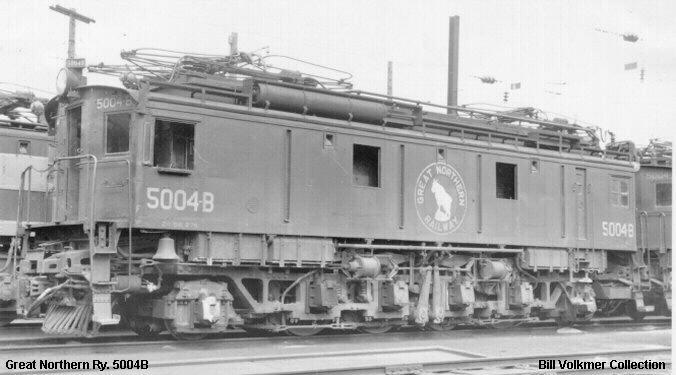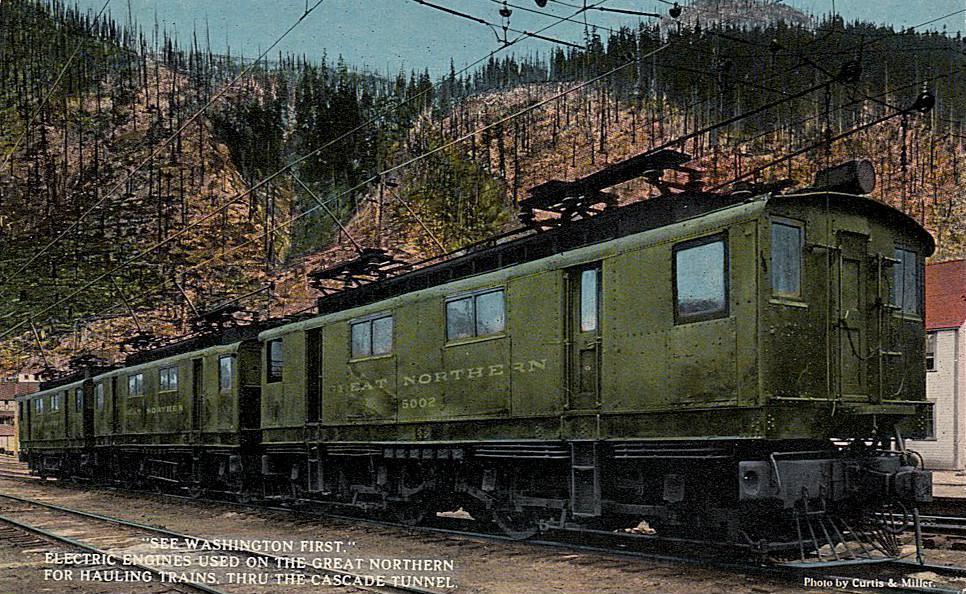The first image is the image on the left, the second image is the image on the right. Analyze the images presented: Is the assertion "One image has a train in front of mountains and is in color." valid? Answer yes or no. Yes. 